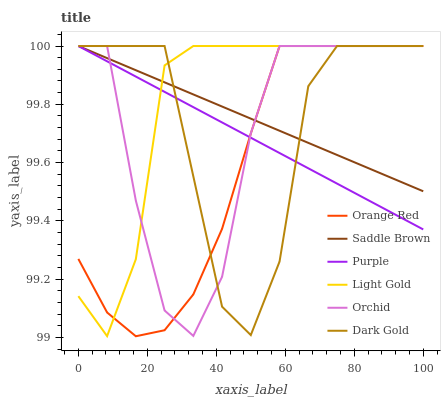Does Orange Red have the minimum area under the curve?
Answer yes or no. Yes. Does Light Gold have the maximum area under the curve?
Answer yes or no. Yes. Does Purple have the minimum area under the curve?
Answer yes or no. No. Does Purple have the maximum area under the curve?
Answer yes or no. No. Is Purple the smoothest?
Answer yes or no. Yes. Is Dark Gold the roughest?
Answer yes or no. Yes. Is Saddle Brown the smoothest?
Answer yes or no. No. Is Saddle Brown the roughest?
Answer yes or no. No. Does Purple have the lowest value?
Answer yes or no. No. Does Orchid have the highest value?
Answer yes or no. Yes. Does Dark Gold intersect Light Gold?
Answer yes or no. Yes. Is Dark Gold less than Light Gold?
Answer yes or no. No. Is Dark Gold greater than Light Gold?
Answer yes or no. No. 